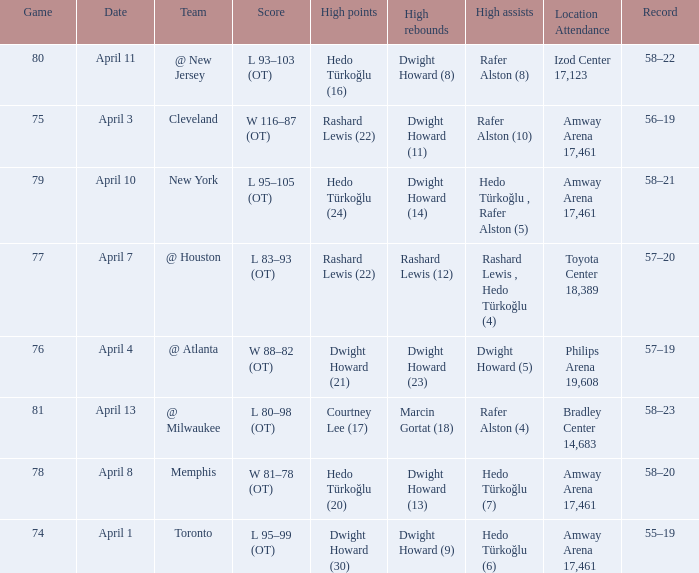Which player had the highest points in game 79? Hedo Türkoğlu (24). 